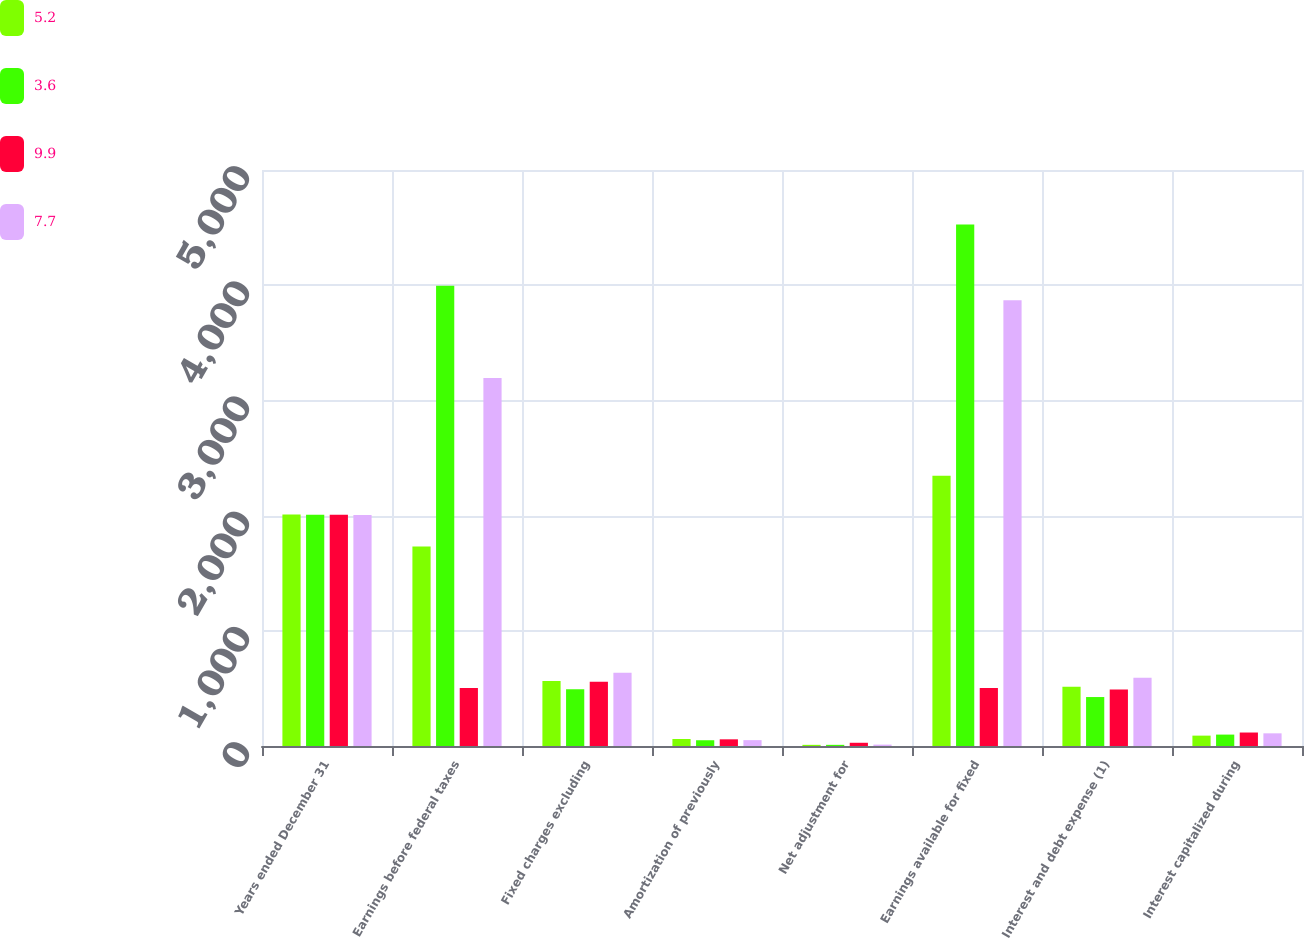Convert chart to OTSL. <chart><loc_0><loc_0><loc_500><loc_500><stacked_bar_chart><ecel><fcel>Years ended December 31<fcel>Earnings before federal taxes<fcel>Fixed charges excluding<fcel>Amortization of previously<fcel>Net adjustment for<fcel>Earnings available for fixed<fcel>Interest and debt expense (1)<fcel>Interest capitalized during<nl><fcel>5.2<fcel>2009<fcel>1731<fcel>564<fcel>61<fcel>10<fcel>2346<fcel>514<fcel>90<nl><fcel>3.6<fcel>2008<fcel>3995<fcel>492<fcel>50<fcel>10<fcel>4527<fcel>425<fcel>99<nl><fcel>9.9<fcel>2007<fcel>503<fcel>557<fcel>58<fcel>28<fcel>503<fcel>491<fcel>117<nl><fcel>7.7<fcel>2006<fcel>3194<fcel>636<fcel>51<fcel>12<fcel>3869<fcel>593<fcel>110<nl></chart> 